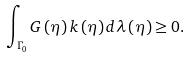Convert formula to latex. <formula><loc_0><loc_0><loc_500><loc_500>\int _ { \Gamma _ { 0 } } G \left ( \eta \right ) k \left ( \eta \right ) d \lambda \left ( \eta \right ) \geq 0 .</formula> 